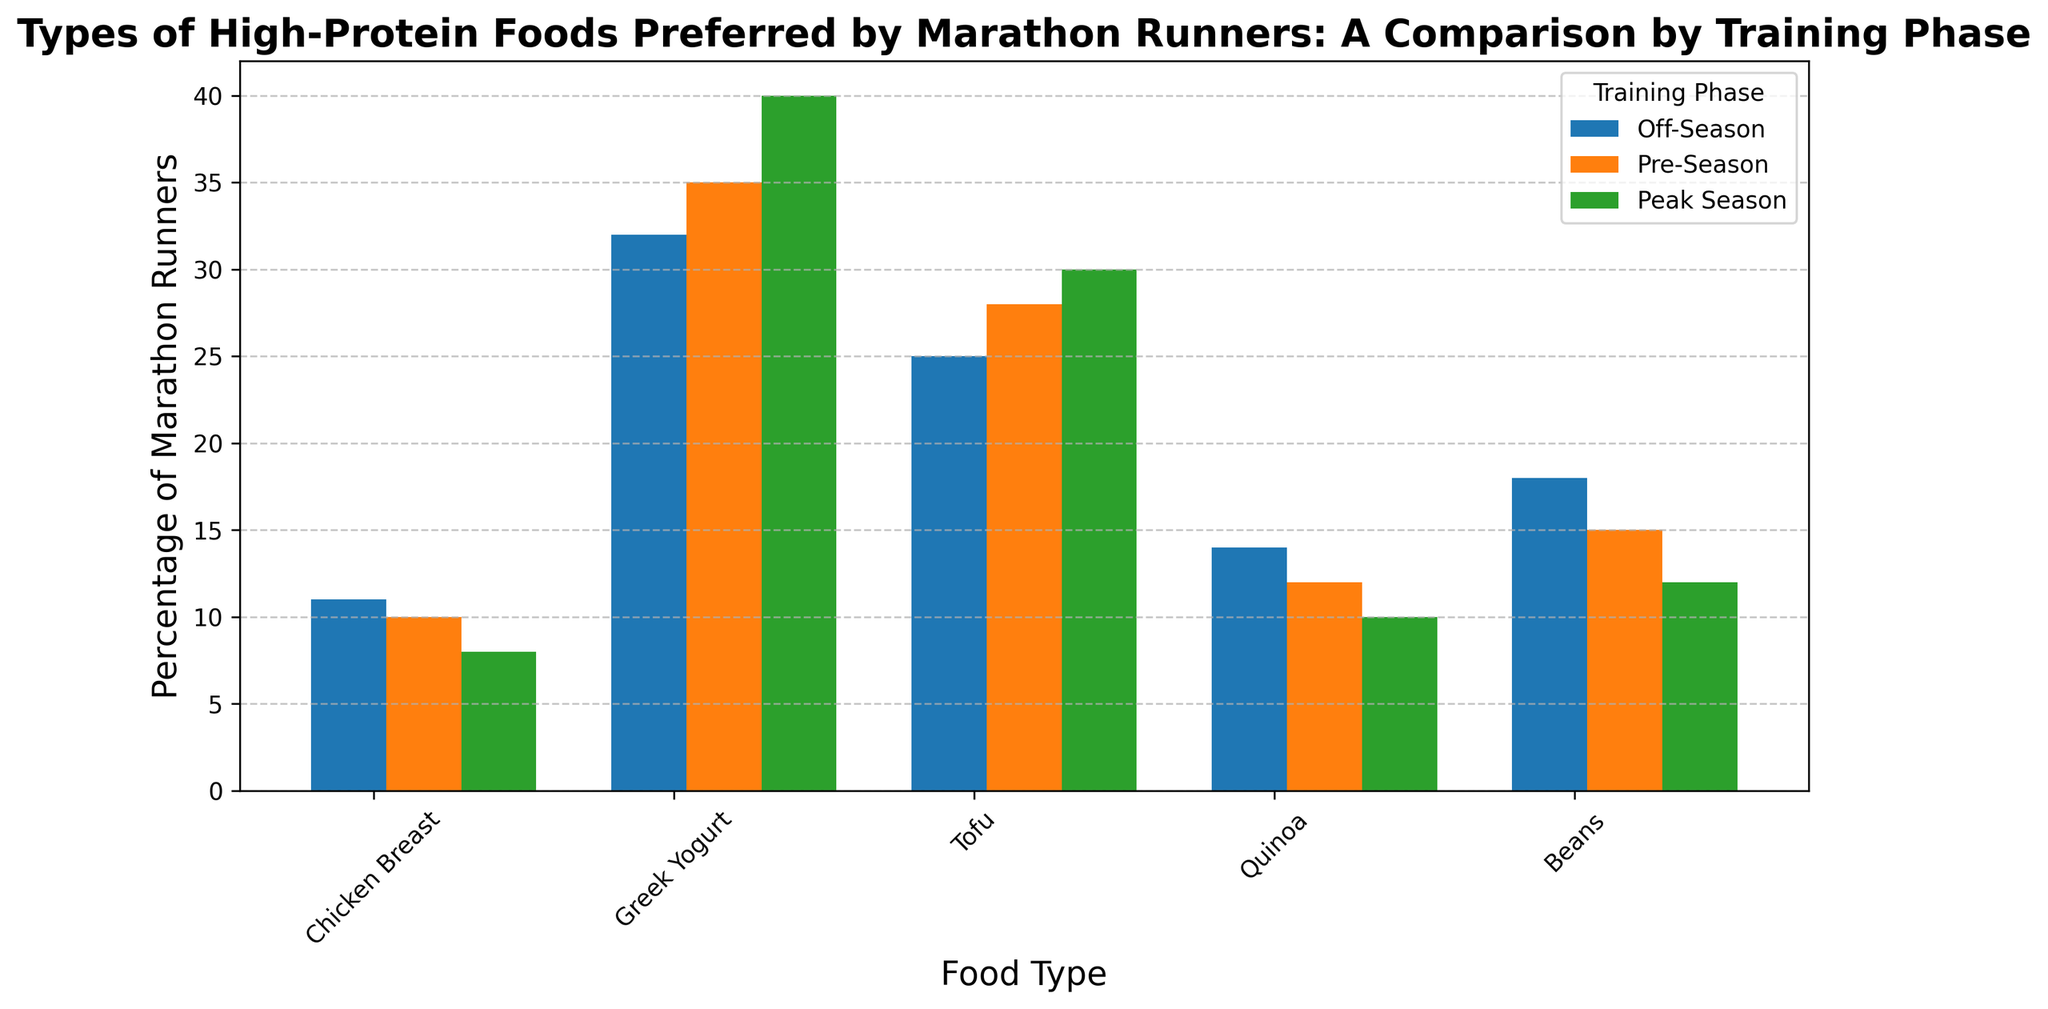What percentage of marathon runners prefer chicken breast in the Off-Season compared to the Peak Season? In the Off-Season, 32% of marathon runners prefer chicken breast. In the Peak Season, 40% of marathon runners prefer chicken breast. Compare these two values to answer the question.
Answer: 32% in Off-Season, 40% in Peak Season How does the preference for Greek yogurt change from Pre-Season to Peak Season? In the Pre-Season, 28% of marathon runners prefer Greek yogurt, while in the Peak Season, 30% of marathon runners prefer it. Find the difference between these two percentages.
Answer: Increases by 2% What is the least preferred type of high-protein food in the Peak Season? In the Peak Season, the percentages for the different food types are: Chicken Breast (40%), Greek Yogurt (30%), Tofu (12%), Quinoa (10%), Beans (8%). The lowest percentage indicates the least preferred food.
Answer: Beans Which training phase shows the highest preference for chicken breast? Compare the percentages of marathon runners preferring chicken breast across the Off-Season (32%), Pre-Season (35%), and Peak Season (40%). The highest percentage determines the phase.
Answer: Peak Season What is the total percentage of marathon runners preferring quinoa across all training phases? Add the percentages of marathon runners preferring quinoa in the Off-Season (14%), Pre-Season (12%), and Peak Season (10%). Sum these values to get the total percentage.
Answer: 36% How much does the preference for tofu decrease from the Off-Season to the Peak Season? In the Off-Season, 18% of marathon runners prefer tofu, while in the Peak Season, 12% prefer it. Subtract the Peak Season percentage from the Off-Season percentage to find the decrease.
Answer: Decreases by 6% Which high-protein food type shows the most consistent preference across all training phases? Compare the changes in percentages across the phases for each food type: Chicken Breast (32%, 35%, 40%), Greek Yogurt (25%, 28%, 30%), Tofu (18%, 15%, 12%), Quinoa (14%, 12%, 10%), Beans (11%, 10%, 8%). The food type with the smallest range of values shows the most consistent preference.
Answer: Beans What is the difference between the highest and lowest percentages of marathon runners preferring Greek yogurt? The percentages of marathon runners preferring Greek yogurt are 25% (Off-Season), 28% (Pre-Season), 30% (Peak Season). Subtract the lowest percentage from the highest percentage to get the difference.
Answer: 5% Across all training phases, which food type has the highest preference? Look at the highest percentages for each food type across all phases: Chicken Breast (40%), Greek Yogurt (30%), Tofu (18%), Quinoa (14%), Beans (11%). The highest percentage indicates the most preferred food type.
Answer: Chicken Breast 